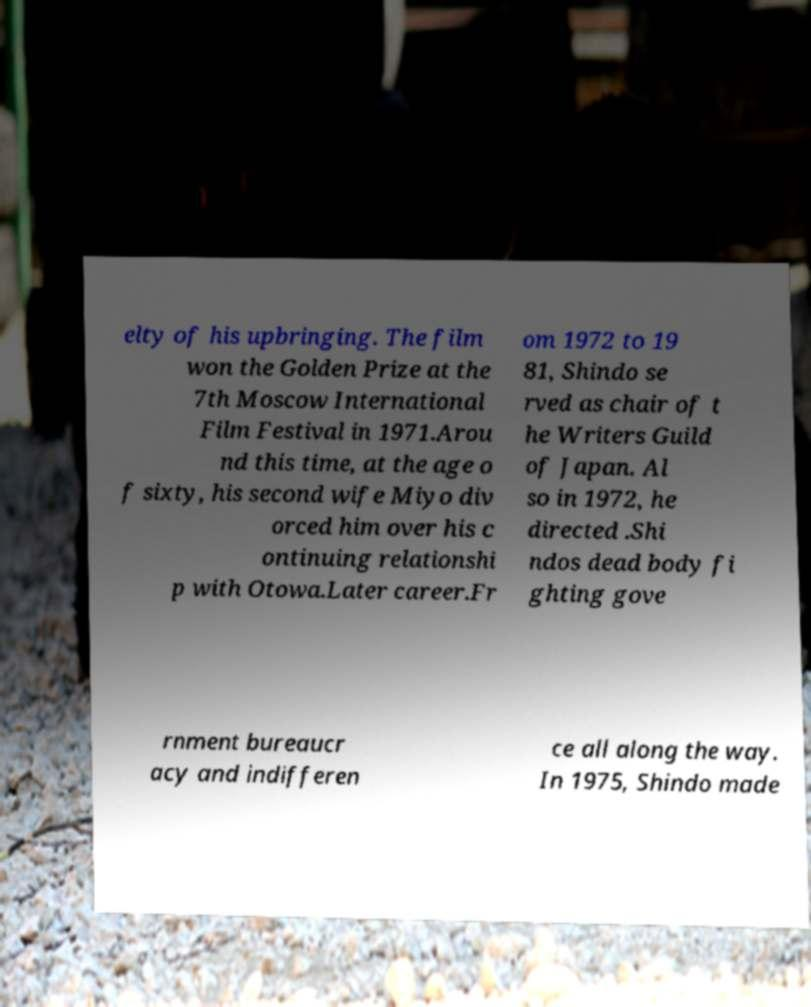Could you assist in decoding the text presented in this image and type it out clearly? elty of his upbringing. The film won the Golden Prize at the 7th Moscow International Film Festival in 1971.Arou nd this time, at the age o f sixty, his second wife Miyo div orced him over his c ontinuing relationshi p with Otowa.Later career.Fr om 1972 to 19 81, Shindo se rved as chair of t he Writers Guild of Japan. Al so in 1972, he directed .Shi ndos dead body fi ghting gove rnment bureaucr acy and indifferen ce all along the way. In 1975, Shindo made 